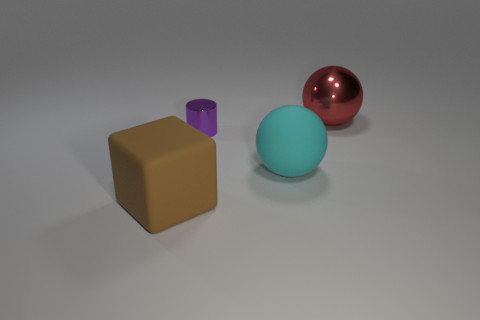What is the shape of the red metallic object that is the same size as the rubber cube?
Your answer should be very brief. Sphere. How many other things are there of the same color as the large metallic thing?
Give a very brief answer. 0. The large matte thing that is on the right side of the large brown cube is what color?
Provide a short and direct response. Cyan. How many other objects are the same material as the brown cube?
Make the answer very short. 1. Is the number of big matte cubes that are on the right side of the large cyan rubber thing greater than the number of cylinders left of the tiny purple cylinder?
Offer a very short reply. No. What number of large matte things are to the left of the small purple object?
Your answer should be compact. 1. Is the large red object made of the same material as the large sphere to the left of the large red thing?
Give a very brief answer. No. Is there anything else that is the same shape as the red thing?
Your answer should be compact. Yes. Is the small purple object made of the same material as the large block?
Ensure brevity in your answer.  No. There is a big matte thing right of the brown object; are there any cylinders that are in front of it?
Keep it short and to the point. No. 